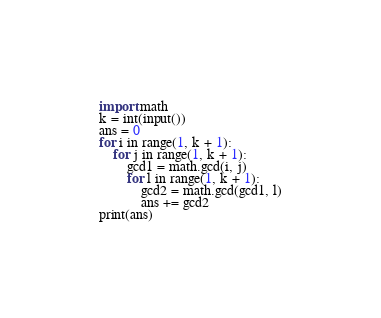Convert code to text. <code><loc_0><loc_0><loc_500><loc_500><_Python_>import math
k = int(input())
ans = 0
for i in range(1, k + 1):
    for j in range(1, k + 1):
        gcd1 = math.gcd(i, j)
        for l in range(1, k + 1):
            gcd2 = math.gcd(gcd1, l)
            ans += gcd2
print(ans)</code> 